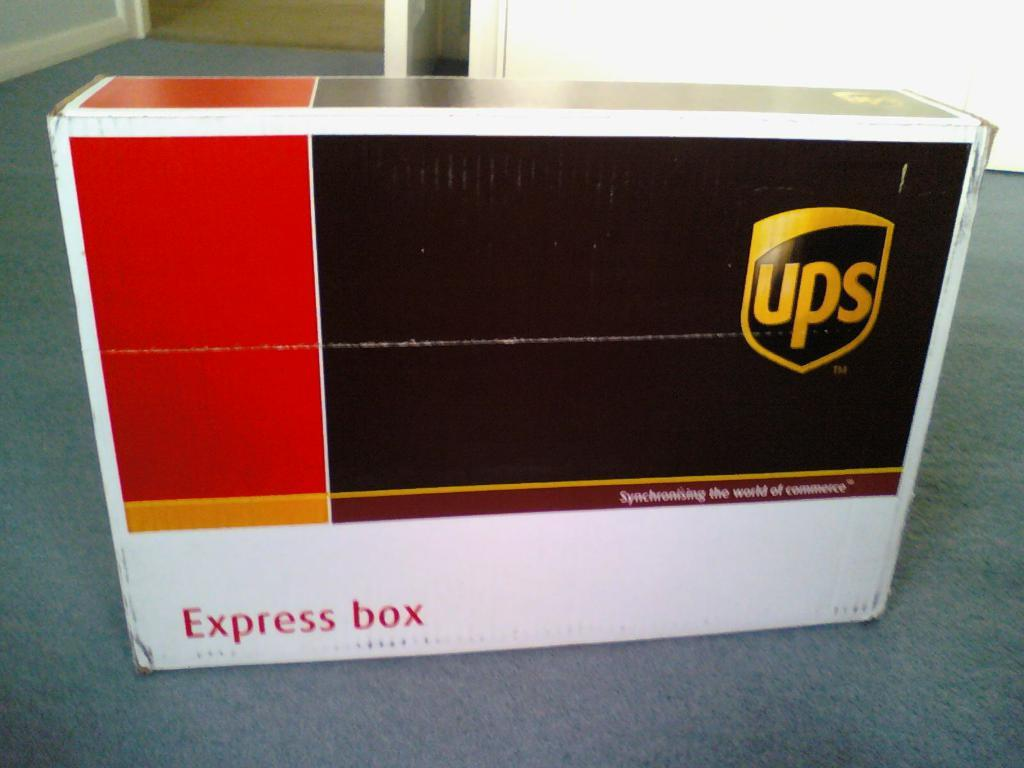What is on the floor inside the house in the image? There is a box on the floor inside the house. What can be seen on the box? The box has the name "UPS" on it. What is the status of the door behind the box? The door behind the box is opened. What type of bulb is being used in the image? There is no bulb present in the image. 